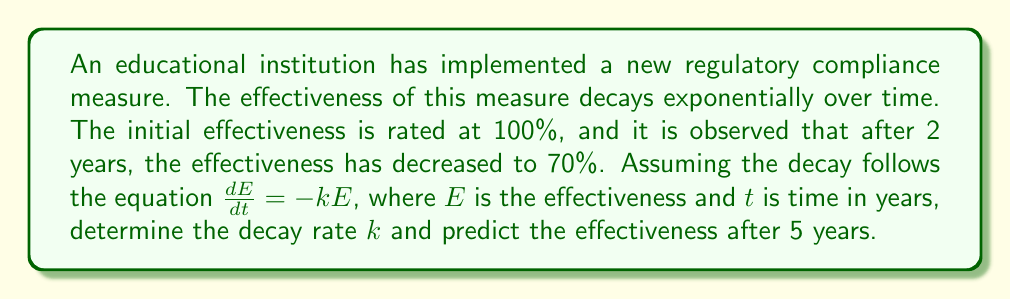What is the answer to this math problem? To solve this problem, we'll follow these steps:

1) The general solution for the given differential equation $\frac{dE}{dt} = -kE$ is:

   $$E(t) = E_0e^{-kt}$$

   where $E_0$ is the initial effectiveness and $k$ is the decay rate.

2) We know that:
   - Initially, $E_0 = 100\%$
   - After 2 years, $E(2) = 70\%$

3) Let's substitute these values into the general solution:

   $$70 = 100e^{-2k}$$

4) Divide both sides by 100:

   $$0.7 = e^{-2k}$$

5) Take the natural logarithm of both sides:

   $$\ln(0.7) = -2k$$

6) Solve for $k$:

   $$k = -\frac{\ln(0.7)}{2} \approx 0.1783$$

7) Now that we have $k$, we can predict the effectiveness after 5 years:

   $$E(5) = 100e^{-0.1783 \cdot 5} \approx 40.98\%$$
Answer: The decay rate $k$ is approximately 0.1783 per year, and the predicted effectiveness after 5 years is approximately 40.98%. 